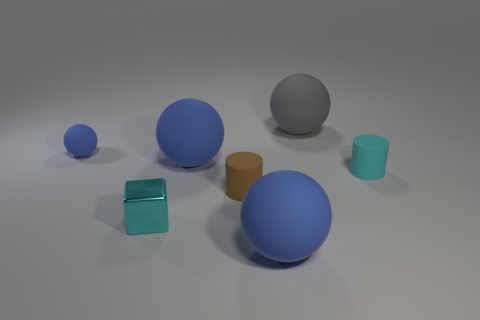Subtract all tiny rubber spheres. How many spheres are left? 3 Add 3 cylinders. How many objects exist? 10 Subtract 2 balls. How many balls are left? 2 Subtract all cyan cylinders. How many cylinders are left? 1 Subtract all cylinders. How many objects are left? 5 Subtract all blue cubes. How many brown cylinders are left? 1 Subtract all big cyan shiny balls. Subtract all small spheres. How many objects are left? 6 Add 5 tiny brown cylinders. How many tiny brown cylinders are left? 6 Add 1 tiny green things. How many tiny green things exist? 1 Subtract 0 green cubes. How many objects are left? 7 